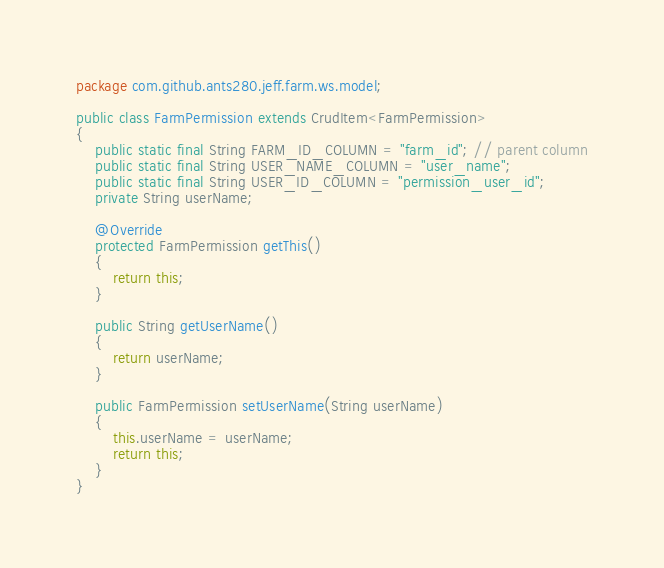<code> <loc_0><loc_0><loc_500><loc_500><_Java_>package com.github.ants280.jeff.farm.ws.model;

public class FarmPermission extends CrudItem<FarmPermission>
{
	public static final String FARM_ID_COLUMN = "farm_id"; // parent column
	public static final String USER_NAME_COLUMN = "user_name";
	public static final String USER_ID_COLUMN = "permission_user_id";
	private String userName;

	@Override
	protected FarmPermission getThis()
	{
		return this;
	}

	public String getUserName()
	{
		return userName;
	}

	public FarmPermission setUserName(String userName)
	{
		this.userName = userName;
		return this;
	}
}
</code> 